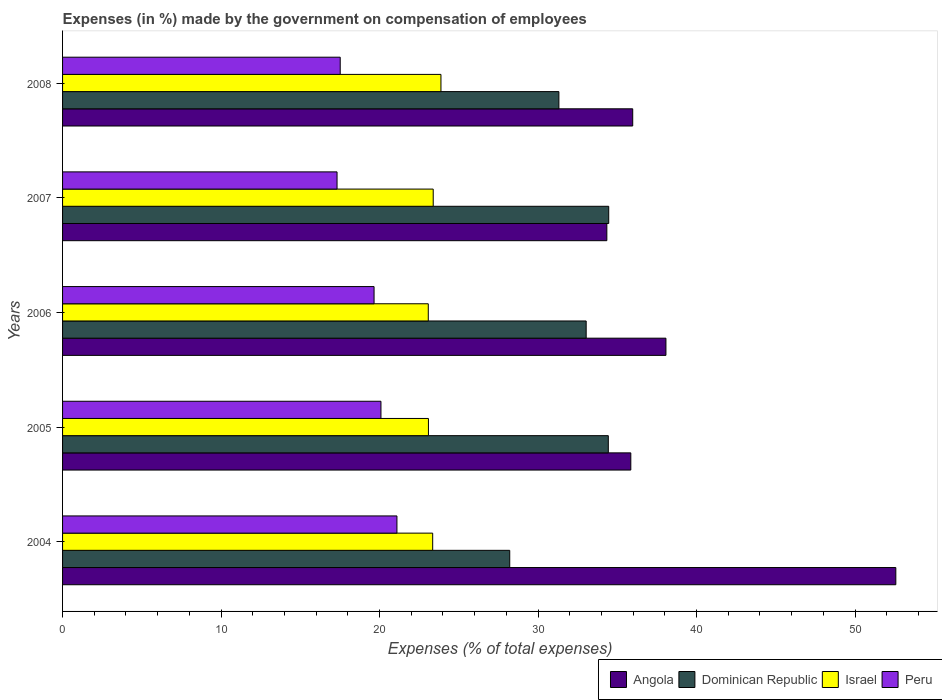How many different coloured bars are there?
Your answer should be compact. 4. Are the number of bars per tick equal to the number of legend labels?
Your answer should be compact. Yes. In how many cases, is the number of bars for a given year not equal to the number of legend labels?
Provide a short and direct response. 0. What is the percentage of expenses made by the government on compensation of employees in Dominican Republic in 2004?
Offer a very short reply. 28.22. Across all years, what is the maximum percentage of expenses made by the government on compensation of employees in Dominican Republic?
Offer a terse response. 34.46. Across all years, what is the minimum percentage of expenses made by the government on compensation of employees in Israel?
Ensure brevity in your answer.  23.08. In which year was the percentage of expenses made by the government on compensation of employees in Israel maximum?
Your response must be concise. 2008. In which year was the percentage of expenses made by the government on compensation of employees in Dominican Republic minimum?
Your response must be concise. 2004. What is the total percentage of expenses made by the government on compensation of employees in Angola in the graph?
Your answer should be compact. 196.82. What is the difference between the percentage of expenses made by the government on compensation of employees in Israel in 2004 and that in 2005?
Your response must be concise. 0.27. What is the difference between the percentage of expenses made by the government on compensation of employees in Dominican Republic in 2004 and the percentage of expenses made by the government on compensation of employees in Angola in 2008?
Make the answer very short. -7.76. What is the average percentage of expenses made by the government on compensation of employees in Peru per year?
Your response must be concise. 19.14. In the year 2005, what is the difference between the percentage of expenses made by the government on compensation of employees in Israel and percentage of expenses made by the government on compensation of employees in Dominican Republic?
Your answer should be compact. -11.35. In how many years, is the percentage of expenses made by the government on compensation of employees in Israel greater than 20 %?
Your response must be concise. 5. What is the ratio of the percentage of expenses made by the government on compensation of employees in Dominican Republic in 2005 to that in 2006?
Your answer should be compact. 1.04. Is the difference between the percentage of expenses made by the government on compensation of employees in Israel in 2006 and 2007 greater than the difference between the percentage of expenses made by the government on compensation of employees in Dominican Republic in 2006 and 2007?
Your answer should be very brief. Yes. What is the difference between the highest and the second highest percentage of expenses made by the government on compensation of employees in Peru?
Your answer should be compact. 1.01. What is the difference between the highest and the lowest percentage of expenses made by the government on compensation of employees in Israel?
Give a very brief answer. 0.8. In how many years, is the percentage of expenses made by the government on compensation of employees in Israel greater than the average percentage of expenses made by the government on compensation of employees in Israel taken over all years?
Keep it short and to the point. 2. Is it the case that in every year, the sum of the percentage of expenses made by the government on compensation of employees in Peru and percentage of expenses made by the government on compensation of employees in Angola is greater than the sum of percentage of expenses made by the government on compensation of employees in Dominican Republic and percentage of expenses made by the government on compensation of employees in Israel?
Offer a very short reply. No. What does the 2nd bar from the top in 2006 represents?
Provide a succinct answer. Israel. What does the 4th bar from the bottom in 2008 represents?
Offer a very short reply. Peru. How many bars are there?
Your answer should be very brief. 20. Are all the bars in the graph horizontal?
Your answer should be very brief. Yes. What is the difference between two consecutive major ticks on the X-axis?
Ensure brevity in your answer.  10. Are the values on the major ticks of X-axis written in scientific E-notation?
Provide a succinct answer. No. Does the graph contain grids?
Provide a short and direct response. No. Where does the legend appear in the graph?
Provide a short and direct response. Bottom right. How many legend labels are there?
Make the answer very short. 4. What is the title of the graph?
Offer a very short reply. Expenses (in %) made by the government on compensation of employees. What is the label or title of the X-axis?
Offer a very short reply. Expenses (% of total expenses). What is the label or title of the Y-axis?
Your response must be concise. Years. What is the Expenses (% of total expenses) in Angola in 2004?
Your response must be concise. 52.58. What is the Expenses (% of total expenses) in Dominican Republic in 2004?
Give a very brief answer. 28.22. What is the Expenses (% of total expenses) of Israel in 2004?
Provide a short and direct response. 23.35. What is the Expenses (% of total expenses) in Peru in 2004?
Your answer should be very brief. 21.1. What is the Expenses (% of total expenses) of Angola in 2005?
Make the answer very short. 35.86. What is the Expenses (% of total expenses) in Dominican Republic in 2005?
Offer a terse response. 34.43. What is the Expenses (% of total expenses) of Israel in 2005?
Keep it short and to the point. 23.09. What is the Expenses (% of total expenses) of Peru in 2005?
Your answer should be very brief. 20.09. What is the Expenses (% of total expenses) in Angola in 2006?
Your response must be concise. 38.07. What is the Expenses (% of total expenses) of Dominican Republic in 2006?
Provide a short and direct response. 33.04. What is the Expenses (% of total expenses) in Israel in 2006?
Your response must be concise. 23.08. What is the Expenses (% of total expenses) of Peru in 2006?
Offer a terse response. 19.65. What is the Expenses (% of total expenses) of Angola in 2007?
Ensure brevity in your answer.  34.34. What is the Expenses (% of total expenses) of Dominican Republic in 2007?
Provide a succinct answer. 34.46. What is the Expenses (% of total expenses) in Israel in 2007?
Offer a very short reply. 23.39. What is the Expenses (% of total expenses) of Peru in 2007?
Provide a short and direct response. 17.32. What is the Expenses (% of total expenses) of Angola in 2008?
Provide a succinct answer. 35.98. What is the Expenses (% of total expenses) in Dominican Republic in 2008?
Keep it short and to the point. 31.32. What is the Expenses (% of total expenses) in Israel in 2008?
Give a very brief answer. 23.87. What is the Expenses (% of total expenses) of Peru in 2008?
Your response must be concise. 17.52. Across all years, what is the maximum Expenses (% of total expenses) in Angola?
Keep it short and to the point. 52.58. Across all years, what is the maximum Expenses (% of total expenses) of Dominican Republic?
Your response must be concise. 34.46. Across all years, what is the maximum Expenses (% of total expenses) of Israel?
Provide a short and direct response. 23.87. Across all years, what is the maximum Expenses (% of total expenses) of Peru?
Your response must be concise. 21.1. Across all years, what is the minimum Expenses (% of total expenses) in Angola?
Give a very brief answer. 34.34. Across all years, what is the minimum Expenses (% of total expenses) of Dominican Republic?
Provide a short and direct response. 28.22. Across all years, what is the minimum Expenses (% of total expenses) in Israel?
Offer a terse response. 23.08. Across all years, what is the minimum Expenses (% of total expenses) of Peru?
Your response must be concise. 17.32. What is the total Expenses (% of total expenses) in Angola in the graph?
Your response must be concise. 196.82. What is the total Expenses (% of total expenses) of Dominican Republic in the graph?
Your response must be concise. 161.47. What is the total Expenses (% of total expenses) of Israel in the graph?
Give a very brief answer. 116.78. What is the total Expenses (% of total expenses) of Peru in the graph?
Make the answer very short. 95.68. What is the difference between the Expenses (% of total expenses) of Angola in 2004 and that in 2005?
Offer a terse response. 16.72. What is the difference between the Expenses (% of total expenses) in Dominican Republic in 2004 and that in 2005?
Make the answer very short. -6.22. What is the difference between the Expenses (% of total expenses) in Israel in 2004 and that in 2005?
Make the answer very short. 0.27. What is the difference between the Expenses (% of total expenses) in Peru in 2004 and that in 2005?
Give a very brief answer. 1.01. What is the difference between the Expenses (% of total expenses) of Angola in 2004 and that in 2006?
Make the answer very short. 14.51. What is the difference between the Expenses (% of total expenses) in Dominican Republic in 2004 and that in 2006?
Your answer should be compact. -4.82. What is the difference between the Expenses (% of total expenses) of Israel in 2004 and that in 2006?
Provide a succinct answer. 0.28. What is the difference between the Expenses (% of total expenses) of Peru in 2004 and that in 2006?
Your answer should be very brief. 1.44. What is the difference between the Expenses (% of total expenses) in Angola in 2004 and that in 2007?
Keep it short and to the point. 18.23. What is the difference between the Expenses (% of total expenses) in Dominican Republic in 2004 and that in 2007?
Provide a short and direct response. -6.25. What is the difference between the Expenses (% of total expenses) in Israel in 2004 and that in 2007?
Your response must be concise. -0.03. What is the difference between the Expenses (% of total expenses) in Peru in 2004 and that in 2007?
Ensure brevity in your answer.  3.78. What is the difference between the Expenses (% of total expenses) in Angola in 2004 and that in 2008?
Offer a terse response. 16.6. What is the difference between the Expenses (% of total expenses) of Dominican Republic in 2004 and that in 2008?
Give a very brief answer. -3.1. What is the difference between the Expenses (% of total expenses) in Israel in 2004 and that in 2008?
Provide a short and direct response. -0.52. What is the difference between the Expenses (% of total expenses) of Peru in 2004 and that in 2008?
Make the answer very short. 3.58. What is the difference between the Expenses (% of total expenses) in Angola in 2005 and that in 2006?
Provide a short and direct response. -2.22. What is the difference between the Expenses (% of total expenses) of Dominican Republic in 2005 and that in 2006?
Ensure brevity in your answer.  1.4. What is the difference between the Expenses (% of total expenses) of Israel in 2005 and that in 2006?
Ensure brevity in your answer.  0.01. What is the difference between the Expenses (% of total expenses) in Peru in 2005 and that in 2006?
Provide a succinct answer. 0.43. What is the difference between the Expenses (% of total expenses) in Angola in 2005 and that in 2007?
Offer a very short reply. 1.51. What is the difference between the Expenses (% of total expenses) of Dominican Republic in 2005 and that in 2007?
Give a very brief answer. -0.03. What is the difference between the Expenses (% of total expenses) in Israel in 2005 and that in 2007?
Keep it short and to the point. -0.3. What is the difference between the Expenses (% of total expenses) of Peru in 2005 and that in 2007?
Make the answer very short. 2.77. What is the difference between the Expenses (% of total expenses) in Angola in 2005 and that in 2008?
Provide a short and direct response. -0.12. What is the difference between the Expenses (% of total expenses) in Dominican Republic in 2005 and that in 2008?
Provide a short and direct response. 3.12. What is the difference between the Expenses (% of total expenses) in Israel in 2005 and that in 2008?
Keep it short and to the point. -0.79. What is the difference between the Expenses (% of total expenses) of Peru in 2005 and that in 2008?
Offer a very short reply. 2.57. What is the difference between the Expenses (% of total expenses) of Angola in 2006 and that in 2007?
Provide a succinct answer. 3.73. What is the difference between the Expenses (% of total expenses) in Dominican Republic in 2006 and that in 2007?
Provide a succinct answer. -1.42. What is the difference between the Expenses (% of total expenses) in Israel in 2006 and that in 2007?
Ensure brevity in your answer.  -0.31. What is the difference between the Expenses (% of total expenses) in Peru in 2006 and that in 2007?
Offer a very short reply. 2.34. What is the difference between the Expenses (% of total expenses) in Angola in 2006 and that in 2008?
Your answer should be compact. 2.1. What is the difference between the Expenses (% of total expenses) of Dominican Republic in 2006 and that in 2008?
Give a very brief answer. 1.72. What is the difference between the Expenses (% of total expenses) of Israel in 2006 and that in 2008?
Offer a terse response. -0.8. What is the difference between the Expenses (% of total expenses) of Peru in 2006 and that in 2008?
Offer a very short reply. 2.14. What is the difference between the Expenses (% of total expenses) of Angola in 2007 and that in 2008?
Keep it short and to the point. -1.63. What is the difference between the Expenses (% of total expenses) of Dominican Republic in 2007 and that in 2008?
Ensure brevity in your answer.  3.14. What is the difference between the Expenses (% of total expenses) of Israel in 2007 and that in 2008?
Your response must be concise. -0.49. What is the difference between the Expenses (% of total expenses) in Angola in 2004 and the Expenses (% of total expenses) in Dominican Republic in 2005?
Your response must be concise. 18.14. What is the difference between the Expenses (% of total expenses) of Angola in 2004 and the Expenses (% of total expenses) of Israel in 2005?
Keep it short and to the point. 29.49. What is the difference between the Expenses (% of total expenses) of Angola in 2004 and the Expenses (% of total expenses) of Peru in 2005?
Ensure brevity in your answer.  32.49. What is the difference between the Expenses (% of total expenses) in Dominican Republic in 2004 and the Expenses (% of total expenses) in Israel in 2005?
Keep it short and to the point. 5.13. What is the difference between the Expenses (% of total expenses) in Dominican Republic in 2004 and the Expenses (% of total expenses) in Peru in 2005?
Offer a very short reply. 8.13. What is the difference between the Expenses (% of total expenses) in Israel in 2004 and the Expenses (% of total expenses) in Peru in 2005?
Ensure brevity in your answer.  3.26. What is the difference between the Expenses (% of total expenses) in Angola in 2004 and the Expenses (% of total expenses) in Dominican Republic in 2006?
Your answer should be compact. 19.54. What is the difference between the Expenses (% of total expenses) in Angola in 2004 and the Expenses (% of total expenses) in Israel in 2006?
Your response must be concise. 29.5. What is the difference between the Expenses (% of total expenses) in Angola in 2004 and the Expenses (% of total expenses) in Peru in 2006?
Provide a succinct answer. 32.92. What is the difference between the Expenses (% of total expenses) in Dominican Republic in 2004 and the Expenses (% of total expenses) in Israel in 2006?
Give a very brief answer. 5.14. What is the difference between the Expenses (% of total expenses) in Dominican Republic in 2004 and the Expenses (% of total expenses) in Peru in 2006?
Your response must be concise. 8.56. What is the difference between the Expenses (% of total expenses) in Israel in 2004 and the Expenses (% of total expenses) in Peru in 2006?
Give a very brief answer. 3.7. What is the difference between the Expenses (% of total expenses) in Angola in 2004 and the Expenses (% of total expenses) in Dominican Republic in 2007?
Provide a short and direct response. 18.12. What is the difference between the Expenses (% of total expenses) in Angola in 2004 and the Expenses (% of total expenses) in Israel in 2007?
Give a very brief answer. 29.19. What is the difference between the Expenses (% of total expenses) of Angola in 2004 and the Expenses (% of total expenses) of Peru in 2007?
Make the answer very short. 35.26. What is the difference between the Expenses (% of total expenses) of Dominican Republic in 2004 and the Expenses (% of total expenses) of Israel in 2007?
Your answer should be compact. 4.83. What is the difference between the Expenses (% of total expenses) of Dominican Republic in 2004 and the Expenses (% of total expenses) of Peru in 2007?
Provide a succinct answer. 10.9. What is the difference between the Expenses (% of total expenses) of Israel in 2004 and the Expenses (% of total expenses) of Peru in 2007?
Your answer should be very brief. 6.03. What is the difference between the Expenses (% of total expenses) of Angola in 2004 and the Expenses (% of total expenses) of Dominican Republic in 2008?
Offer a very short reply. 21.26. What is the difference between the Expenses (% of total expenses) in Angola in 2004 and the Expenses (% of total expenses) in Israel in 2008?
Give a very brief answer. 28.7. What is the difference between the Expenses (% of total expenses) in Angola in 2004 and the Expenses (% of total expenses) in Peru in 2008?
Provide a succinct answer. 35.06. What is the difference between the Expenses (% of total expenses) in Dominican Republic in 2004 and the Expenses (% of total expenses) in Israel in 2008?
Offer a terse response. 4.34. What is the difference between the Expenses (% of total expenses) in Dominican Republic in 2004 and the Expenses (% of total expenses) in Peru in 2008?
Your answer should be compact. 10.7. What is the difference between the Expenses (% of total expenses) of Israel in 2004 and the Expenses (% of total expenses) of Peru in 2008?
Provide a succinct answer. 5.83. What is the difference between the Expenses (% of total expenses) of Angola in 2005 and the Expenses (% of total expenses) of Dominican Republic in 2006?
Offer a very short reply. 2.82. What is the difference between the Expenses (% of total expenses) in Angola in 2005 and the Expenses (% of total expenses) in Israel in 2006?
Your answer should be compact. 12.78. What is the difference between the Expenses (% of total expenses) of Angola in 2005 and the Expenses (% of total expenses) of Peru in 2006?
Provide a short and direct response. 16.2. What is the difference between the Expenses (% of total expenses) of Dominican Republic in 2005 and the Expenses (% of total expenses) of Israel in 2006?
Give a very brief answer. 11.36. What is the difference between the Expenses (% of total expenses) of Dominican Republic in 2005 and the Expenses (% of total expenses) of Peru in 2006?
Your response must be concise. 14.78. What is the difference between the Expenses (% of total expenses) in Israel in 2005 and the Expenses (% of total expenses) in Peru in 2006?
Your answer should be very brief. 3.43. What is the difference between the Expenses (% of total expenses) of Angola in 2005 and the Expenses (% of total expenses) of Dominican Republic in 2007?
Your answer should be very brief. 1.39. What is the difference between the Expenses (% of total expenses) in Angola in 2005 and the Expenses (% of total expenses) in Israel in 2007?
Your answer should be very brief. 12.47. What is the difference between the Expenses (% of total expenses) in Angola in 2005 and the Expenses (% of total expenses) in Peru in 2007?
Make the answer very short. 18.54. What is the difference between the Expenses (% of total expenses) of Dominican Republic in 2005 and the Expenses (% of total expenses) of Israel in 2007?
Give a very brief answer. 11.05. What is the difference between the Expenses (% of total expenses) of Dominican Republic in 2005 and the Expenses (% of total expenses) of Peru in 2007?
Offer a terse response. 17.12. What is the difference between the Expenses (% of total expenses) in Israel in 2005 and the Expenses (% of total expenses) in Peru in 2007?
Offer a terse response. 5.77. What is the difference between the Expenses (% of total expenses) in Angola in 2005 and the Expenses (% of total expenses) in Dominican Republic in 2008?
Your answer should be very brief. 4.54. What is the difference between the Expenses (% of total expenses) in Angola in 2005 and the Expenses (% of total expenses) in Israel in 2008?
Your response must be concise. 11.98. What is the difference between the Expenses (% of total expenses) of Angola in 2005 and the Expenses (% of total expenses) of Peru in 2008?
Your answer should be very brief. 18.34. What is the difference between the Expenses (% of total expenses) in Dominican Republic in 2005 and the Expenses (% of total expenses) in Israel in 2008?
Make the answer very short. 10.56. What is the difference between the Expenses (% of total expenses) in Dominican Republic in 2005 and the Expenses (% of total expenses) in Peru in 2008?
Keep it short and to the point. 16.92. What is the difference between the Expenses (% of total expenses) in Israel in 2005 and the Expenses (% of total expenses) in Peru in 2008?
Make the answer very short. 5.57. What is the difference between the Expenses (% of total expenses) of Angola in 2006 and the Expenses (% of total expenses) of Dominican Republic in 2007?
Ensure brevity in your answer.  3.61. What is the difference between the Expenses (% of total expenses) of Angola in 2006 and the Expenses (% of total expenses) of Israel in 2007?
Make the answer very short. 14.68. What is the difference between the Expenses (% of total expenses) in Angola in 2006 and the Expenses (% of total expenses) in Peru in 2007?
Your answer should be compact. 20.75. What is the difference between the Expenses (% of total expenses) of Dominican Republic in 2006 and the Expenses (% of total expenses) of Israel in 2007?
Your answer should be very brief. 9.65. What is the difference between the Expenses (% of total expenses) in Dominican Republic in 2006 and the Expenses (% of total expenses) in Peru in 2007?
Offer a very short reply. 15.72. What is the difference between the Expenses (% of total expenses) in Israel in 2006 and the Expenses (% of total expenses) in Peru in 2007?
Offer a very short reply. 5.76. What is the difference between the Expenses (% of total expenses) in Angola in 2006 and the Expenses (% of total expenses) in Dominican Republic in 2008?
Your answer should be compact. 6.75. What is the difference between the Expenses (% of total expenses) of Angola in 2006 and the Expenses (% of total expenses) of Israel in 2008?
Make the answer very short. 14.2. What is the difference between the Expenses (% of total expenses) of Angola in 2006 and the Expenses (% of total expenses) of Peru in 2008?
Keep it short and to the point. 20.55. What is the difference between the Expenses (% of total expenses) of Dominican Republic in 2006 and the Expenses (% of total expenses) of Israel in 2008?
Your response must be concise. 9.16. What is the difference between the Expenses (% of total expenses) of Dominican Republic in 2006 and the Expenses (% of total expenses) of Peru in 2008?
Your response must be concise. 15.52. What is the difference between the Expenses (% of total expenses) of Israel in 2006 and the Expenses (% of total expenses) of Peru in 2008?
Your response must be concise. 5.56. What is the difference between the Expenses (% of total expenses) of Angola in 2007 and the Expenses (% of total expenses) of Dominican Republic in 2008?
Ensure brevity in your answer.  3.03. What is the difference between the Expenses (% of total expenses) of Angola in 2007 and the Expenses (% of total expenses) of Israel in 2008?
Provide a succinct answer. 10.47. What is the difference between the Expenses (% of total expenses) in Angola in 2007 and the Expenses (% of total expenses) in Peru in 2008?
Offer a very short reply. 16.82. What is the difference between the Expenses (% of total expenses) in Dominican Republic in 2007 and the Expenses (% of total expenses) in Israel in 2008?
Give a very brief answer. 10.59. What is the difference between the Expenses (% of total expenses) in Dominican Republic in 2007 and the Expenses (% of total expenses) in Peru in 2008?
Your response must be concise. 16.94. What is the difference between the Expenses (% of total expenses) of Israel in 2007 and the Expenses (% of total expenses) of Peru in 2008?
Provide a succinct answer. 5.87. What is the average Expenses (% of total expenses) in Angola per year?
Provide a short and direct response. 39.36. What is the average Expenses (% of total expenses) in Dominican Republic per year?
Your response must be concise. 32.29. What is the average Expenses (% of total expenses) in Israel per year?
Your response must be concise. 23.36. What is the average Expenses (% of total expenses) in Peru per year?
Ensure brevity in your answer.  19.14. In the year 2004, what is the difference between the Expenses (% of total expenses) in Angola and Expenses (% of total expenses) in Dominican Republic?
Offer a very short reply. 24.36. In the year 2004, what is the difference between the Expenses (% of total expenses) in Angola and Expenses (% of total expenses) in Israel?
Keep it short and to the point. 29.22. In the year 2004, what is the difference between the Expenses (% of total expenses) of Angola and Expenses (% of total expenses) of Peru?
Your answer should be compact. 31.48. In the year 2004, what is the difference between the Expenses (% of total expenses) in Dominican Republic and Expenses (% of total expenses) in Israel?
Make the answer very short. 4.86. In the year 2004, what is the difference between the Expenses (% of total expenses) of Dominican Republic and Expenses (% of total expenses) of Peru?
Provide a short and direct response. 7.12. In the year 2004, what is the difference between the Expenses (% of total expenses) in Israel and Expenses (% of total expenses) in Peru?
Ensure brevity in your answer.  2.26. In the year 2005, what is the difference between the Expenses (% of total expenses) in Angola and Expenses (% of total expenses) in Dominican Republic?
Give a very brief answer. 1.42. In the year 2005, what is the difference between the Expenses (% of total expenses) in Angola and Expenses (% of total expenses) in Israel?
Keep it short and to the point. 12.77. In the year 2005, what is the difference between the Expenses (% of total expenses) in Angola and Expenses (% of total expenses) in Peru?
Keep it short and to the point. 15.77. In the year 2005, what is the difference between the Expenses (% of total expenses) in Dominican Republic and Expenses (% of total expenses) in Israel?
Your answer should be very brief. 11.35. In the year 2005, what is the difference between the Expenses (% of total expenses) of Dominican Republic and Expenses (% of total expenses) of Peru?
Make the answer very short. 14.35. In the year 2005, what is the difference between the Expenses (% of total expenses) of Israel and Expenses (% of total expenses) of Peru?
Provide a short and direct response. 3. In the year 2006, what is the difference between the Expenses (% of total expenses) in Angola and Expenses (% of total expenses) in Dominican Republic?
Your response must be concise. 5.03. In the year 2006, what is the difference between the Expenses (% of total expenses) of Angola and Expenses (% of total expenses) of Israel?
Offer a terse response. 14.99. In the year 2006, what is the difference between the Expenses (% of total expenses) of Angola and Expenses (% of total expenses) of Peru?
Give a very brief answer. 18.42. In the year 2006, what is the difference between the Expenses (% of total expenses) in Dominican Republic and Expenses (% of total expenses) in Israel?
Your answer should be very brief. 9.96. In the year 2006, what is the difference between the Expenses (% of total expenses) in Dominican Republic and Expenses (% of total expenses) in Peru?
Your answer should be very brief. 13.38. In the year 2006, what is the difference between the Expenses (% of total expenses) in Israel and Expenses (% of total expenses) in Peru?
Offer a terse response. 3.42. In the year 2007, what is the difference between the Expenses (% of total expenses) of Angola and Expenses (% of total expenses) of Dominican Republic?
Your answer should be very brief. -0.12. In the year 2007, what is the difference between the Expenses (% of total expenses) of Angola and Expenses (% of total expenses) of Israel?
Provide a short and direct response. 10.95. In the year 2007, what is the difference between the Expenses (% of total expenses) in Angola and Expenses (% of total expenses) in Peru?
Give a very brief answer. 17.02. In the year 2007, what is the difference between the Expenses (% of total expenses) of Dominican Republic and Expenses (% of total expenses) of Israel?
Your response must be concise. 11.07. In the year 2007, what is the difference between the Expenses (% of total expenses) in Dominican Republic and Expenses (% of total expenses) in Peru?
Provide a succinct answer. 17.14. In the year 2007, what is the difference between the Expenses (% of total expenses) in Israel and Expenses (% of total expenses) in Peru?
Your answer should be compact. 6.07. In the year 2008, what is the difference between the Expenses (% of total expenses) of Angola and Expenses (% of total expenses) of Dominican Republic?
Make the answer very short. 4.66. In the year 2008, what is the difference between the Expenses (% of total expenses) in Angola and Expenses (% of total expenses) in Israel?
Make the answer very short. 12.1. In the year 2008, what is the difference between the Expenses (% of total expenses) in Angola and Expenses (% of total expenses) in Peru?
Provide a short and direct response. 18.46. In the year 2008, what is the difference between the Expenses (% of total expenses) in Dominican Republic and Expenses (% of total expenses) in Israel?
Keep it short and to the point. 7.44. In the year 2008, what is the difference between the Expenses (% of total expenses) in Dominican Republic and Expenses (% of total expenses) in Peru?
Ensure brevity in your answer.  13.8. In the year 2008, what is the difference between the Expenses (% of total expenses) in Israel and Expenses (% of total expenses) in Peru?
Ensure brevity in your answer.  6.36. What is the ratio of the Expenses (% of total expenses) of Angola in 2004 to that in 2005?
Offer a terse response. 1.47. What is the ratio of the Expenses (% of total expenses) in Dominican Republic in 2004 to that in 2005?
Make the answer very short. 0.82. What is the ratio of the Expenses (% of total expenses) in Israel in 2004 to that in 2005?
Offer a terse response. 1.01. What is the ratio of the Expenses (% of total expenses) in Peru in 2004 to that in 2005?
Ensure brevity in your answer.  1.05. What is the ratio of the Expenses (% of total expenses) of Angola in 2004 to that in 2006?
Give a very brief answer. 1.38. What is the ratio of the Expenses (% of total expenses) in Dominican Republic in 2004 to that in 2006?
Make the answer very short. 0.85. What is the ratio of the Expenses (% of total expenses) of Peru in 2004 to that in 2006?
Ensure brevity in your answer.  1.07. What is the ratio of the Expenses (% of total expenses) of Angola in 2004 to that in 2007?
Your answer should be very brief. 1.53. What is the ratio of the Expenses (% of total expenses) in Dominican Republic in 2004 to that in 2007?
Provide a short and direct response. 0.82. What is the ratio of the Expenses (% of total expenses) in Israel in 2004 to that in 2007?
Keep it short and to the point. 1. What is the ratio of the Expenses (% of total expenses) of Peru in 2004 to that in 2007?
Keep it short and to the point. 1.22. What is the ratio of the Expenses (% of total expenses) of Angola in 2004 to that in 2008?
Ensure brevity in your answer.  1.46. What is the ratio of the Expenses (% of total expenses) in Dominican Republic in 2004 to that in 2008?
Give a very brief answer. 0.9. What is the ratio of the Expenses (% of total expenses) of Israel in 2004 to that in 2008?
Ensure brevity in your answer.  0.98. What is the ratio of the Expenses (% of total expenses) in Peru in 2004 to that in 2008?
Your response must be concise. 1.2. What is the ratio of the Expenses (% of total expenses) of Angola in 2005 to that in 2006?
Your answer should be very brief. 0.94. What is the ratio of the Expenses (% of total expenses) in Dominican Republic in 2005 to that in 2006?
Keep it short and to the point. 1.04. What is the ratio of the Expenses (% of total expenses) of Israel in 2005 to that in 2006?
Give a very brief answer. 1. What is the ratio of the Expenses (% of total expenses) in Peru in 2005 to that in 2006?
Make the answer very short. 1.02. What is the ratio of the Expenses (% of total expenses) of Angola in 2005 to that in 2007?
Provide a short and direct response. 1.04. What is the ratio of the Expenses (% of total expenses) of Dominican Republic in 2005 to that in 2007?
Give a very brief answer. 1. What is the ratio of the Expenses (% of total expenses) in Israel in 2005 to that in 2007?
Keep it short and to the point. 0.99. What is the ratio of the Expenses (% of total expenses) of Peru in 2005 to that in 2007?
Your answer should be very brief. 1.16. What is the ratio of the Expenses (% of total expenses) in Dominican Republic in 2005 to that in 2008?
Provide a short and direct response. 1.1. What is the ratio of the Expenses (% of total expenses) in Israel in 2005 to that in 2008?
Keep it short and to the point. 0.97. What is the ratio of the Expenses (% of total expenses) in Peru in 2005 to that in 2008?
Keep it short and to the point. 1.15. What is the ratio of the Expenses (% of total expenses) of Angola in 2006 to that in 2007?
Your answer should be compact. 1.11. What is the ratio of the Expenses (% of total expenses) of Dominican Republic in 2006 to that in 2007?
Provide a short and direct response. 0.96. What is the ratio of the Expenses (% of total expenses) of Israel in 2006 to that in 2007?
Make the answer very short. 0.99. What is the ratio of the Expenses (% of total expenses) of Peru in 2006 to that in 2007?
Provide a short and direct response. 1.13. What is the ratio of the Expenses (% of total expenses) of Angola in 2006 to that in 2008?
Your answer should be very brief. 1.06. What is the ratio of the Expenses (% of total expenses) in Dominican Republic in 2006 to that in 2008?
Make the answer very short. 1.05. What is the ratio of the Expenses (% of total expenses) in Israel in 2006 to that in 2008?
Offer a terse response. 0.97. What is the ratio of the Expenses (% of total expenses) of Peru in 2006 to that in 2008?
Keep it short and to the point. 1.12. What is the ratio of the Expenses (% of total expenses) of Angola in 2007 to that in 2008?
Give a very brief answer. 0.95. What is the ratio of the Expenses (% of total expenses) of Dominican Republic in 2007 to that in 2008?
Provide a succinct answer. 1.1. What is the ratio of the Expenses (% of total expenses) of Israel in 2007 to that in 2008?
Offer a very short reply. 0.98. What is the difference between the highest and the second highest Expenses (% of total expenses) of Angola?
Provide a short and direct response. 14.51. What is the difference between the highest and the second highest Expenses (% of total expenses) in Dominican Republic?
Give a very brief answer. 0.03. What is the difference between the highest and the second highest Expenses (% of total expenses) in Israel?
Make the answer very short. 0.49. What is the difference between the highest and the second highest Expenses (% of total expenses) of Peru?
Your answer should be very brief. 1.01. What is the difference between the highest and the lowest Expenses (% of total expenses) of Angola?
Your answer should be compact. 18.23. What is the difference between the highest and the lowest Expenses (% of total expenses) of Dominican Republic?
Ensure brevity in your answer.  6.25. What is the difference between the highest and the lowest Expenses (% of total expenses) in Israel?
Offer a terse response. 0.8. What is the difference between the highest and the lowest Expenses (% of total expenses) of Peru?
Your answer should be compact. 3.78. 